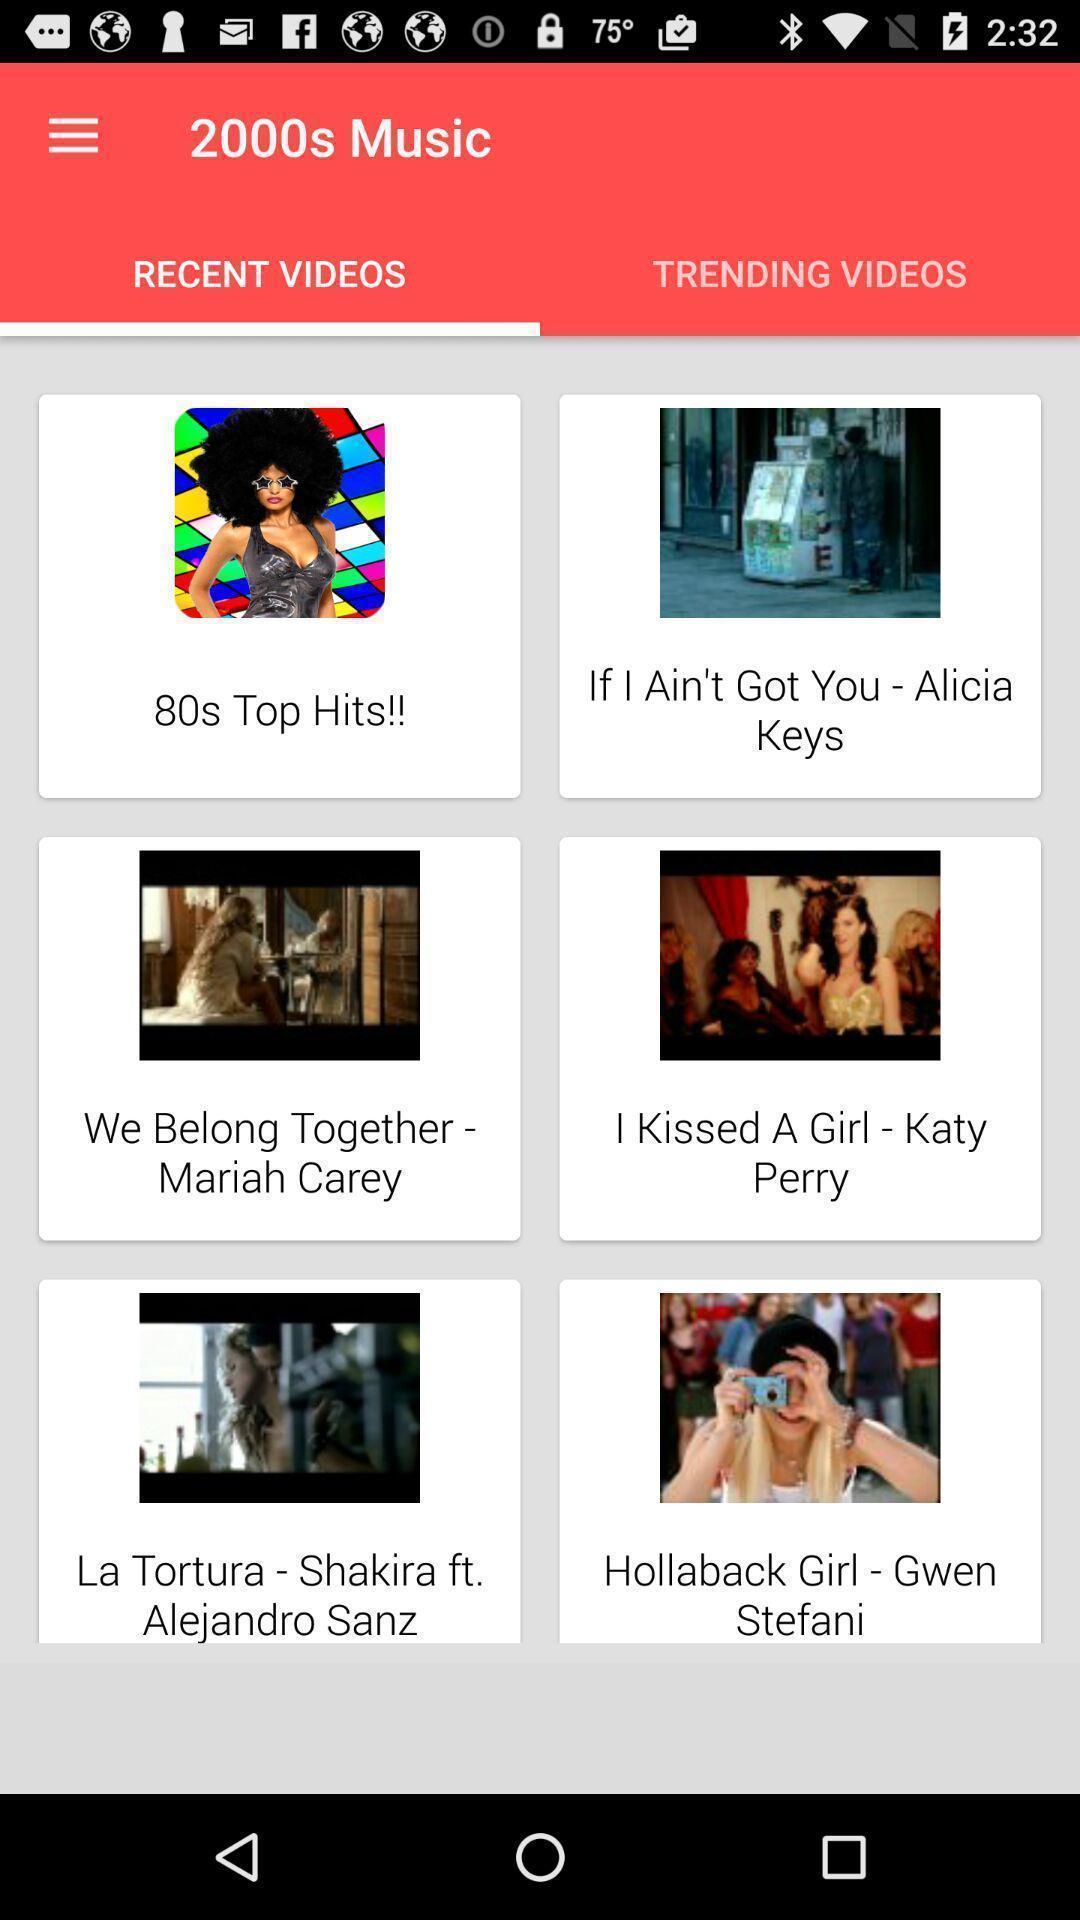Provide a description of this screenshot. Screen shows multiple video in a music app. 